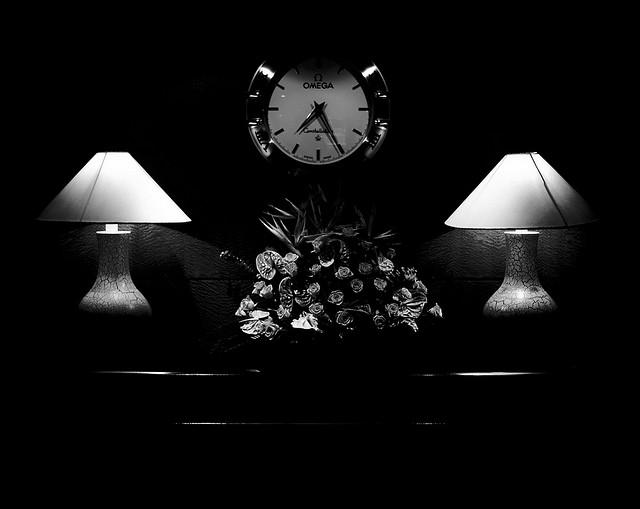Is this daytime?
Quick response, please. No. What time does the clock show?
Concise answer only. 7:25. How many lamps are shown?
Give a very brief answer. 2. 